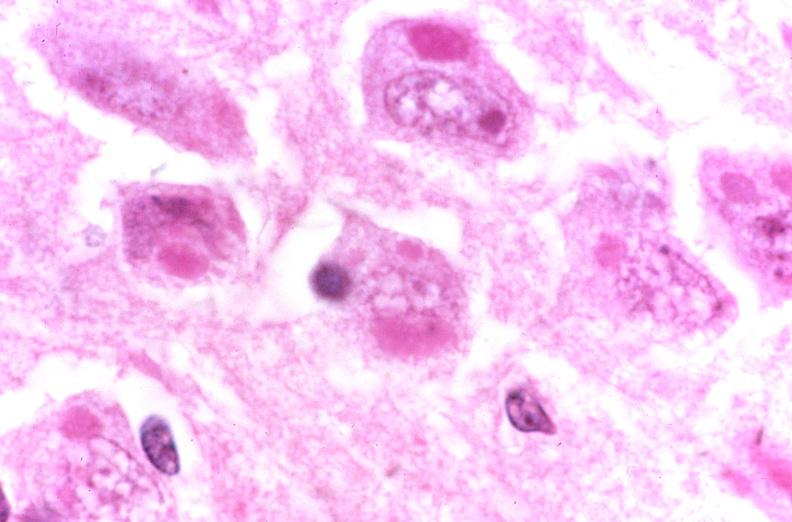where is this?
Answer the question using a single word or phrase. Nervous 